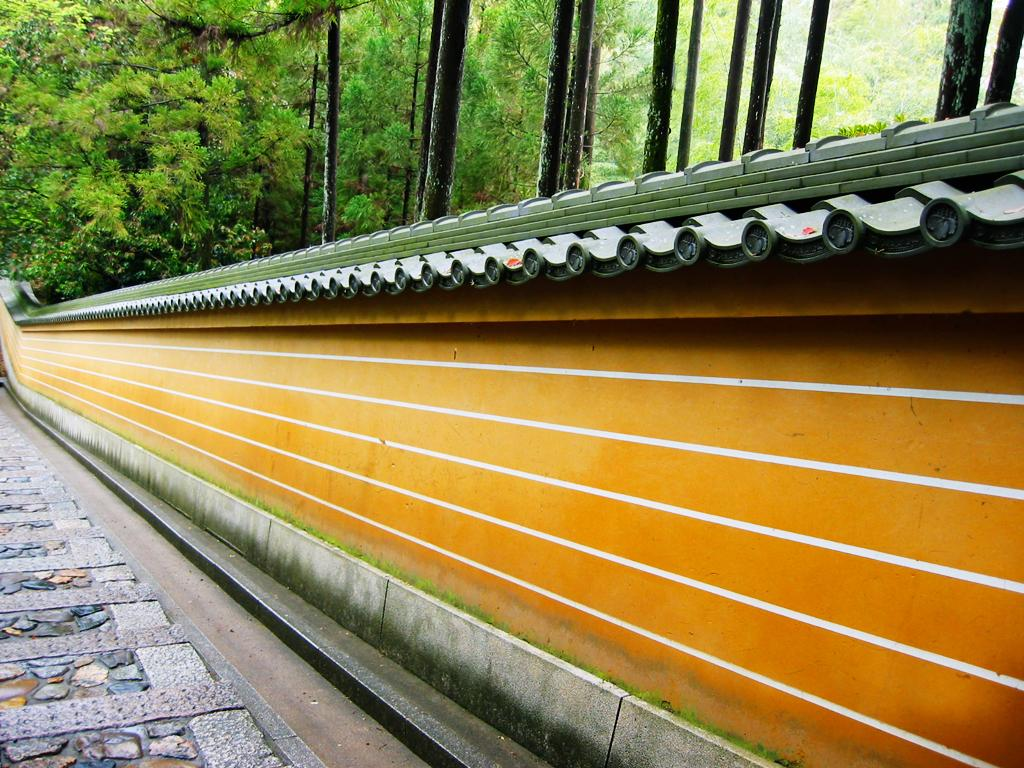What is the primary feature of the image? The primary feature of the image is the presence of many trees. Can you describe any man-made structures in the image? Yes, there is a wall in the image. What is the title of the representative in the image? There is no representative or title present in the image; it simply features trees and a wall. How does the rub interact with the trees in the image? There is no rub present in the image, so it cannot interact with the trees. 